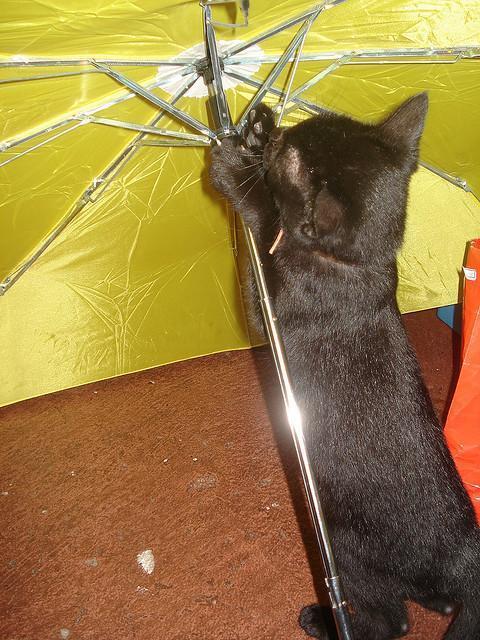How many umbrellas are visible?
Give a very brief answer. 1. 